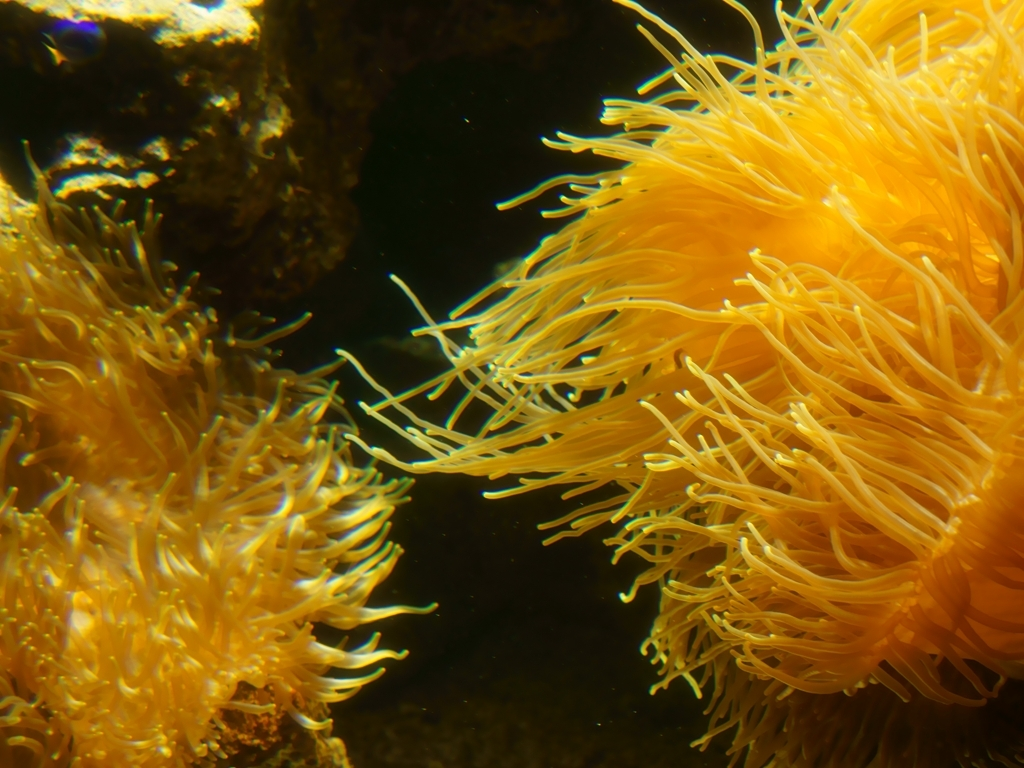What type of marine life is depicted in this image? The image shows a close-up of vibrant yellow sea anemones. These are marine animals characterized by their gelatinous, tentacle-covered bodies, and they often play a vital role in ocean ecosystems. 